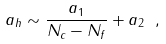<formula> <loc_0><loc_0><loc_500><loc_500>a _ { h } \sim \frac { a _ { 1 } } { N _ { c } - N _ { f } } + a _ { 2 } \ ,</formula> 